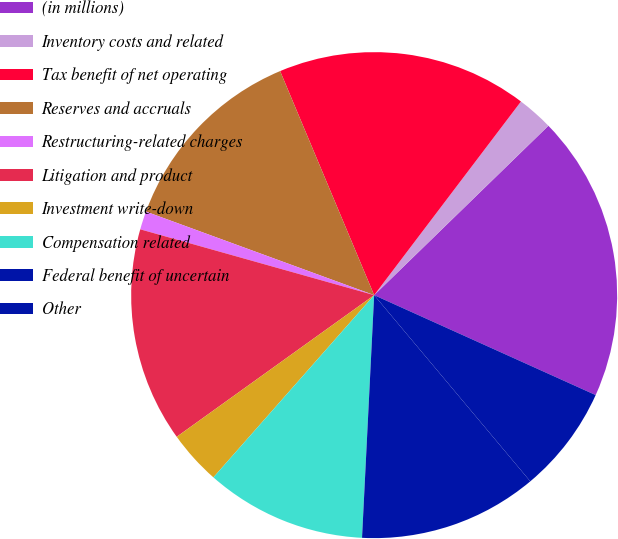<chart> <loc_0><loc_0><loc_500><loc_500><pie_chart><fcel>(in millions)<fcel>Inventory costs and related<fcel>Tax benefit of net operating<fcel>Reserves and accruals<fcel>Restructuring-related charges<fcel>Litigation and product<fcel>Investment write-down<fcel>Compensation related<fcel>Federal benefit of uncertain<fcel>Other<nl><fcel>19.02%<fcel>2.4%<fcel>16.65%<fcel>13.09%<fcel>1.22%<fcel>14.27%<fcel>3.59%<fcel>10.71%<fcel>11.9%<fcel>7.15%<nl></chart> 